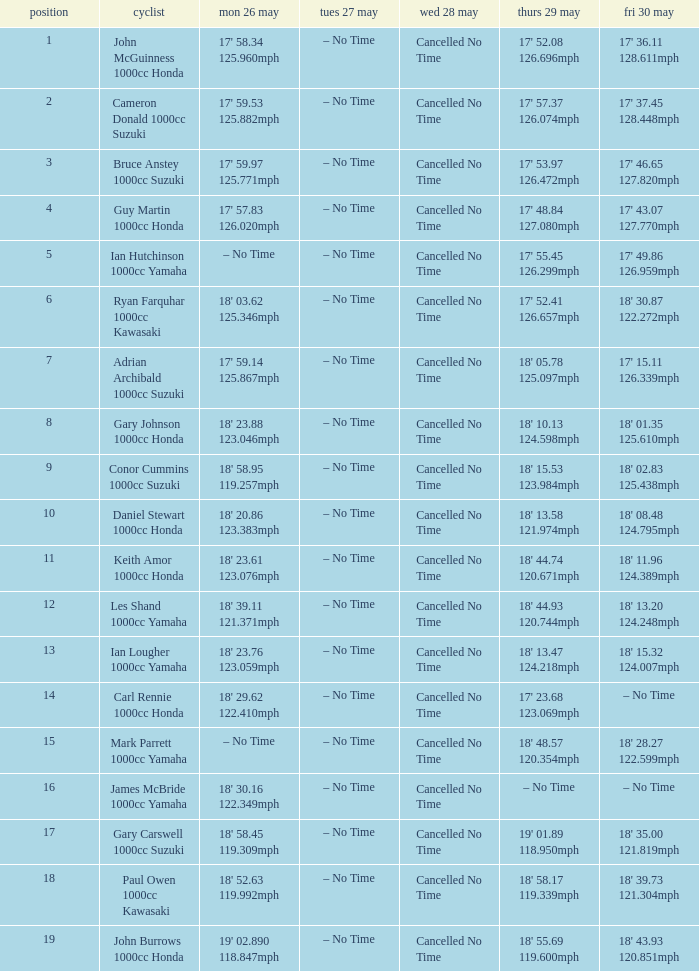What is the numbr for fri may 30 and mon may 26 is 19' 02.890 118.847mph? 18' 43.93 120.851mph. 